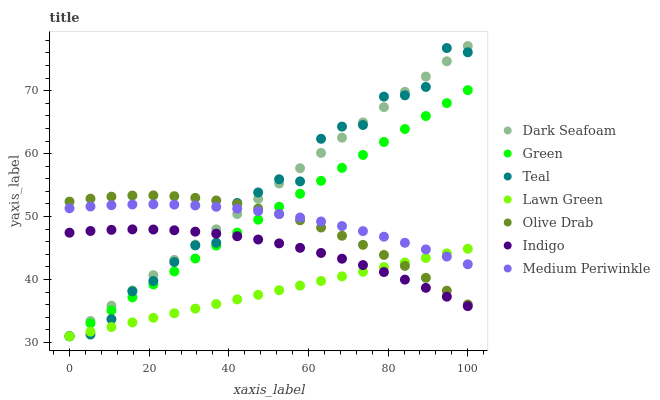Does Lawn Green have the minimum area under the curve?
Answer yes or no. Yes. Does Dark Seafoam have the maximum area under the curve?
Answer yes or no. Yes. Does Indigo have the minimum area under the curve?
Answer yes or no. No. Does Indigo have the maximum area under the curve?
Answer yes or no. No. Is Lawn Green the smoothest?
Answer yes or no. Yes. Is Teal the roughest?
Answer yes or no. Yes. Is Indigo the smoothest?
Answer yes or no. No. Is Indigo the roughest?
Answer yes or no. No. Does Lawn Green have the lowest value?
Answer yes or no. Yes. Does Indigo have the lowest value?
Answer yes or no. No. Does Dark Seafoam have the highest value?
Answer yes or no. Yes. Does Indigo have the highest value?
Answer yes or no. No. Is Indigo less than Olive Drab?
Answer yes or no. Yes. Is Olive Drab greater than Indigo?
Answer yes or no. Yes. Does Dark Seafoam intersect Teal?
Answer yes or no. Yes. Is Dark Seafoam less than Teal?
Answer yes or no. No. Is Dark Seafoam greater than Teal?
Answer yes or no. No. Does Indigo intersect Olive Drab?
Answer yes or no. No. 